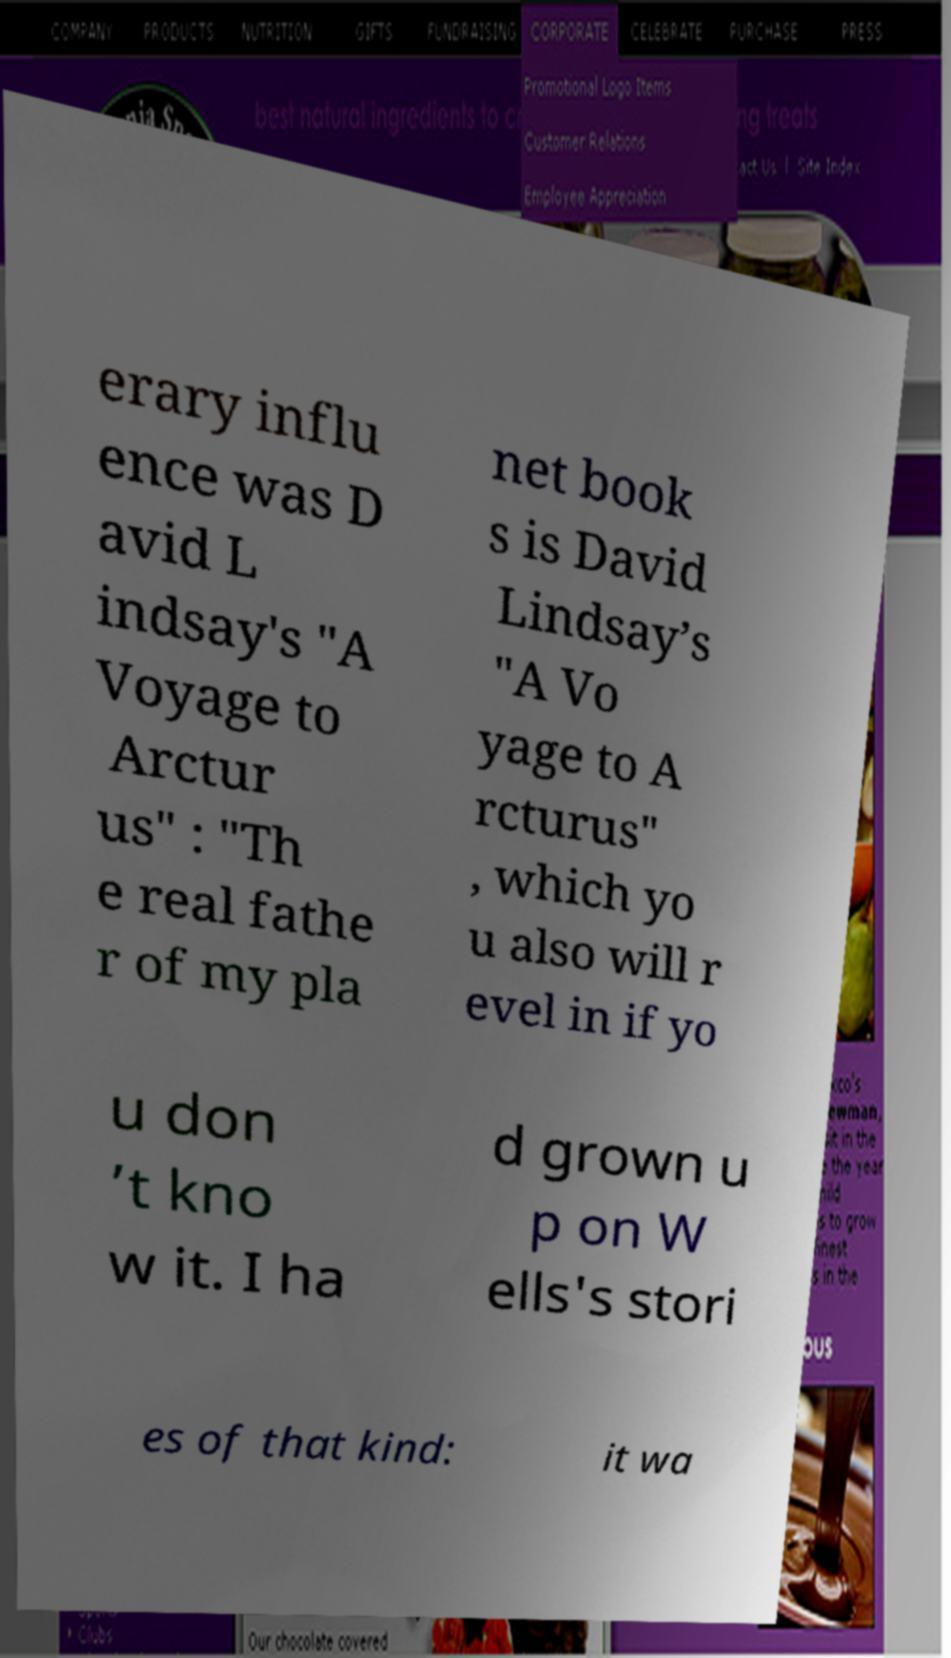Please read and relay the text visible in this image. What does it say? erary influ ence was D avid L indsay's "A Voyage to Arctur us" : "Th e real fathe r of my pla net book s is David Lindsay’s "A Vo yage to A rcturus" , which yo u also will r evel in if yo u don ’t kno w it. I ha d grown u p on W ells's stori es of that kind: it wa 